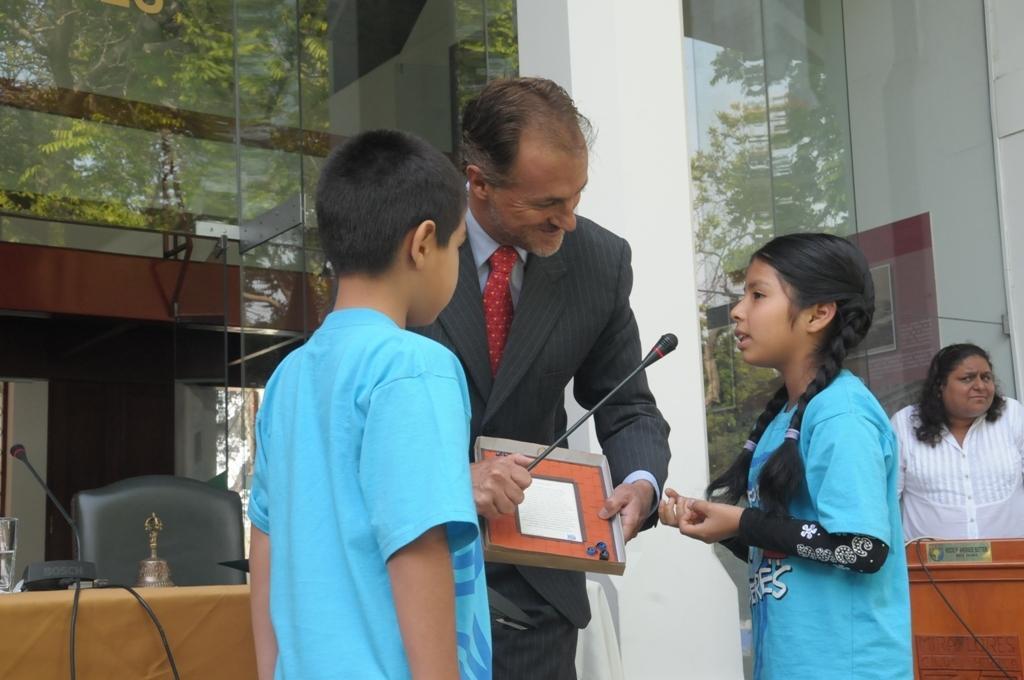In one or two sentences, can you explain what this image depicts? In this image we can see a man is standing. He is wearing suit with shirt and red tie and holding mic and a box in his hand. In front of the man, one boy and girl is there. They are wearing blue color t-shirt. We can see table in the left bottom of the image. On table, we can see glass, mic and some object. We can see one lady on the right side of the image. There is a pillar and glass wall in the background. We can see trees reflection in the glass. 